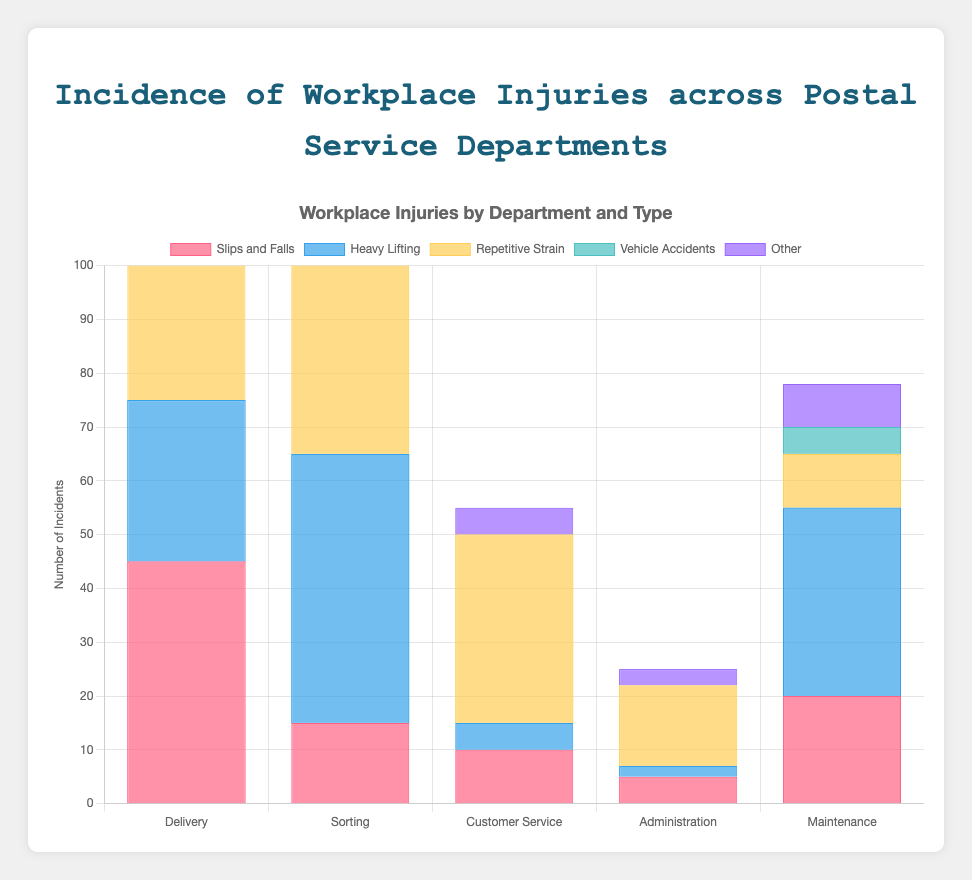Which department experienced the highest number of "Slips and Falls" incidents? First, identify the bar corresponding to "Slips and Falls" for each department. The highest bar in this set represents the department with the highest number. The "Delivery" department has the highest number of incidents with 45.
Answer: Delivery Which two departments have the lowest number of "Vehicle Accidents"? Locate the bars for "Vehicle Accidents" across all departments. Identify the two lowest bars; there are no incidents in "Sorting" and "Customer Service" departments.
Answer: Sorting, Customer Service What is the total number of "Repetitive Strain" injuries across all departments? Add the values for "Repetitive Strain" injuries from each department: 25 (Delivery) + 40 (Sorting) + 35 (Customer Service) + 15 (Administration) + 10 (Maintenance). This sums up to 125.
Answer: 125 Compare the number of "Heavy Lifting" injuries between "Delivery" and "Maintenance" departments. Which has more incidents? Compare the heights of the bars for "Heavy Lifting" in both departments. The "Delivery" department has 30 incidents, while "Maintenance" has 35, so "Maintenance" has more.
Answer: Maintenance How many more "Slips and Falls" incidents does the "Delivery" department have than the "Sorting" department? Subtract the number of "Slips and Falls" incidents in "Sorting" (15) from those in "Delivery" (45). The difference is 30.
Answer: 30 What is the combined total of "Other" incidents reported by "Customer Service" and "Administration" departments? Sum the values for "Other" incidents in "Customer Service" (5) and "Administration" (3). The total is 8.
Answer: 8 Which department experiences the highest overall number of injuries? Sum the number of incidents for each injury type within each department, and compare the totals. "Delivery" adds up to 45+30+25+15+5 = 120. "Sorting" adds up to 15+50+40+0+10 = 115. "Customer Service" total is 10+5+35+0+5 = 55. "Administration" total is 5+2+15+0+3 = 25. "Maintenance" total is 20+35+10+5+8 = 78. "Delivery" has the highest total with 120.
Answer: Delivery How does the number of "Slips and Falls" incidents in "Maintenance" compare to the number of "Repetitive Strain" incidents in "Administration"? "Maintenance" has 20 "Slips and Falls", and "Administration" has 15 "Repetitive Strain" injuries. Therefore, "Maintenance" has more.
Answer: Maintenance What is the difference in total injuries between the department with the highest number of incidents and the one with the lowest? The department with the highest is "Delivery" with 120 incidents, and the lowest is "Administration" with 25. The difference is 120 - 25 = 95.
Answer: 95 